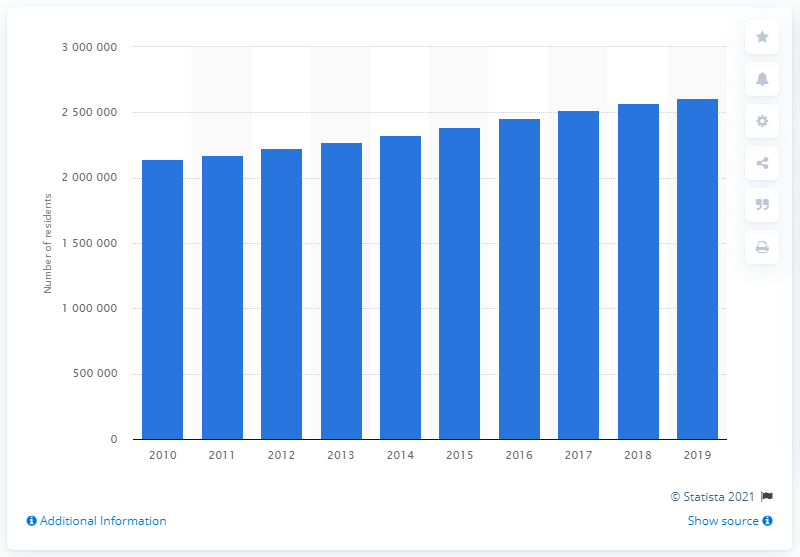Draw attention to some important aspects in this diagram. In 2019, the Orlando-Kissimmee-Sanford metropolitan area was home to a population of 2,608,147 people. 